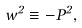Convert formula to latex. <formula><loc_0><loc_0><loc_500><loc_500>w ^ { 2 } \equiv - P ^ { 2 } ,</formula> 